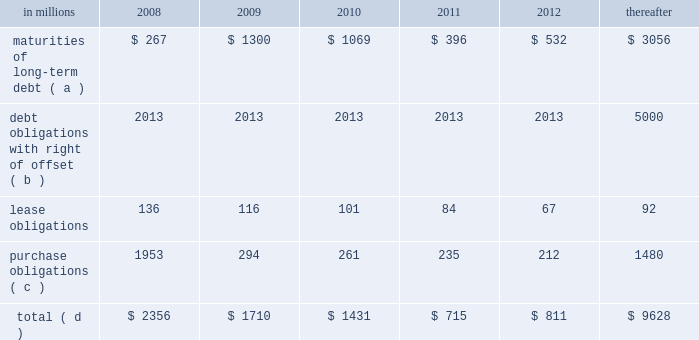Exchanged installment notes totaling approximately $ 4.8 billion and approximately $ 400 million of inter- national paper promissory notes for interests in enti- ties formed to monetize the notes .
International paper determined that it was not the primary benefi- ciary of these entities , and therefore should not consolidate its investments in these entities .
During 2006 , these entities acquired an additional $ 4.8 bil- lion of international paper debt securities for cash , resulting in a total of approximately $ 5.2 billion of international paper debt obligations held by these entities at december 31 , 2006 .
Since international paper has , and intends to affect , a legal right to offset its obligations under these debt instruments with its investments in the entities , international paper has offset $ 5.0 billion of interest in the entities against $ 5.0 billion of international paper debt obligations held by the entities as of december 31 , 2007 .
International paper also holds variable interests in two financing entities that were used to monetize long-term notes received from sales of forestlands in 2002 and 2001 .
See note 8 of the notes to consolidated financial statements in item 8 .
Financial statements and supplementary data for a further discussion of these transactions .
Capital resources outlook for 2008 international paper expects to be able to meet pro- jected capital expenditures , service existing debt and meet working capital and dividend requirements during 2008 through current cash balances and cash from operations , supplemented as required by its various existing credit facilities .
International paper has approximately $ 2.5 billion of committed bank credit agreements , which management believes is adequate to cover expected operating cash flow variability during our industry 2019s economic cycles .
The agreements generally provide for interest rates at a floating rate index plus a pre-determined margin dependent upon international paper 2019s credit rating .
The agreements include a $ 1.5 billion fully commit- ted revolving bank credit agreement that expires in march 2011 and has a facility fee of 0.10% ( 0.10 % ) payable quarterly .
These agreements also include up to $ 1.0 billion of available commercial paper-based financ- ings under a receivables securitization program that expires in october 2009 with a facility fee of 0.10% ( 0.10 % ) .
At december 31 , 2007 , there were no borrowings under either the bank credit agreements or receiv- ables securitization program .
The company will continue to rely upon debt and capital markets for the majority of any necessary long-term funding not provided by operating cash flows .
Funding decisions will be guided by our capi- tal structure planning objectives .
The primary goals of the company 2019s capital structure planning are to maximize financial flexibility and preserve liquidity while reducing interest expense .
The majority of international paper 2019s debt is accessed through global public capital markets where we have a wide base of investors .
The company was in compliance with all its debt covenants at december 31 , 2007 .
Principal financial covenants include maintenance of a minimum net worth , defined as the sum of common stock , paid-in capital and retained earnings , less treasury stock , plus any goodwill impairment charges , of $ 9 billion ; and a maximum total debt to capital ratio , defined as total debt divided by total debt plus net worth , of 60% ( 60 % ) .
Maintaining an investment grade credit rating is an important element of international paper 2019s financing strategy .
At december 31 , 2007 , the company held long-term credit ratings of bbb ( stable outlook ) and baa3 ( stable outlook ) by standard & poor 2019s ( s&p ) and moody 2019s investor services ( moody 2019s ) , respectively .
The company currently has short-term credit ratings by s&p and moody 2019s of a-2 and p-3 , respectively .
Contractual obligations for future payments under existing debt and lease commitments and purchase obligations at december 31 , 2007 , were as follows : in millions 2008 2009 2010 2011 2012 thereafter maturities of long-term debt ( a ) $ 267 $ 1300 $ 1069 $ 396 $ 532 $ 3056 debt obligations with right of offset ( b ) 2013 2013 2013 2013 2013 5000 .
( a ) total debt includes scheduled principal payments only .
( b ) represents debt obligations borrowed from non-consolidated variable interest entities for which international paper has , and intends to affect , a legal right to offset these obligations with investments held in the entities .
Accordingly , in its con- solidated balance sheet at december 31 , 2007 , international paper has offset approximately $ 5.0 billion of interests in the entities against this $ 5.0 billion of debt obligations held by the entities ( see note 8 in the accompanying consolidated financial statements ) .
( c ) includes $ 2.1 billion relating to fiber supply agreements entered into at the time of the transformation plan forestland sales .
( d ) not included in the above table are unrecognized tax benefits of approximately $ 280 million. .
What percentage of contractual obligations for future payments under existing debt and lease commitments and purchase obligations at december 31 , 2007 for the year of 2009 are due to maturities of long-term debt? 
Computations: (1300 / 1710)
Answer: 0.76023. 